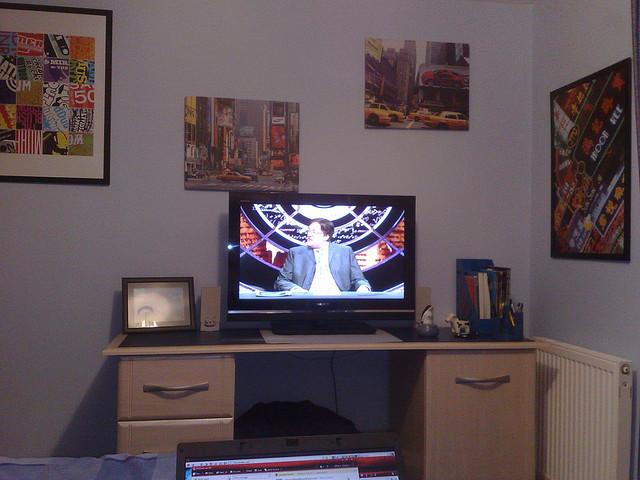What kind of artwork is framed on the left side of the screen on the wall? Please explain your reasoning. american pop. American pop art is usually bold and daring. 